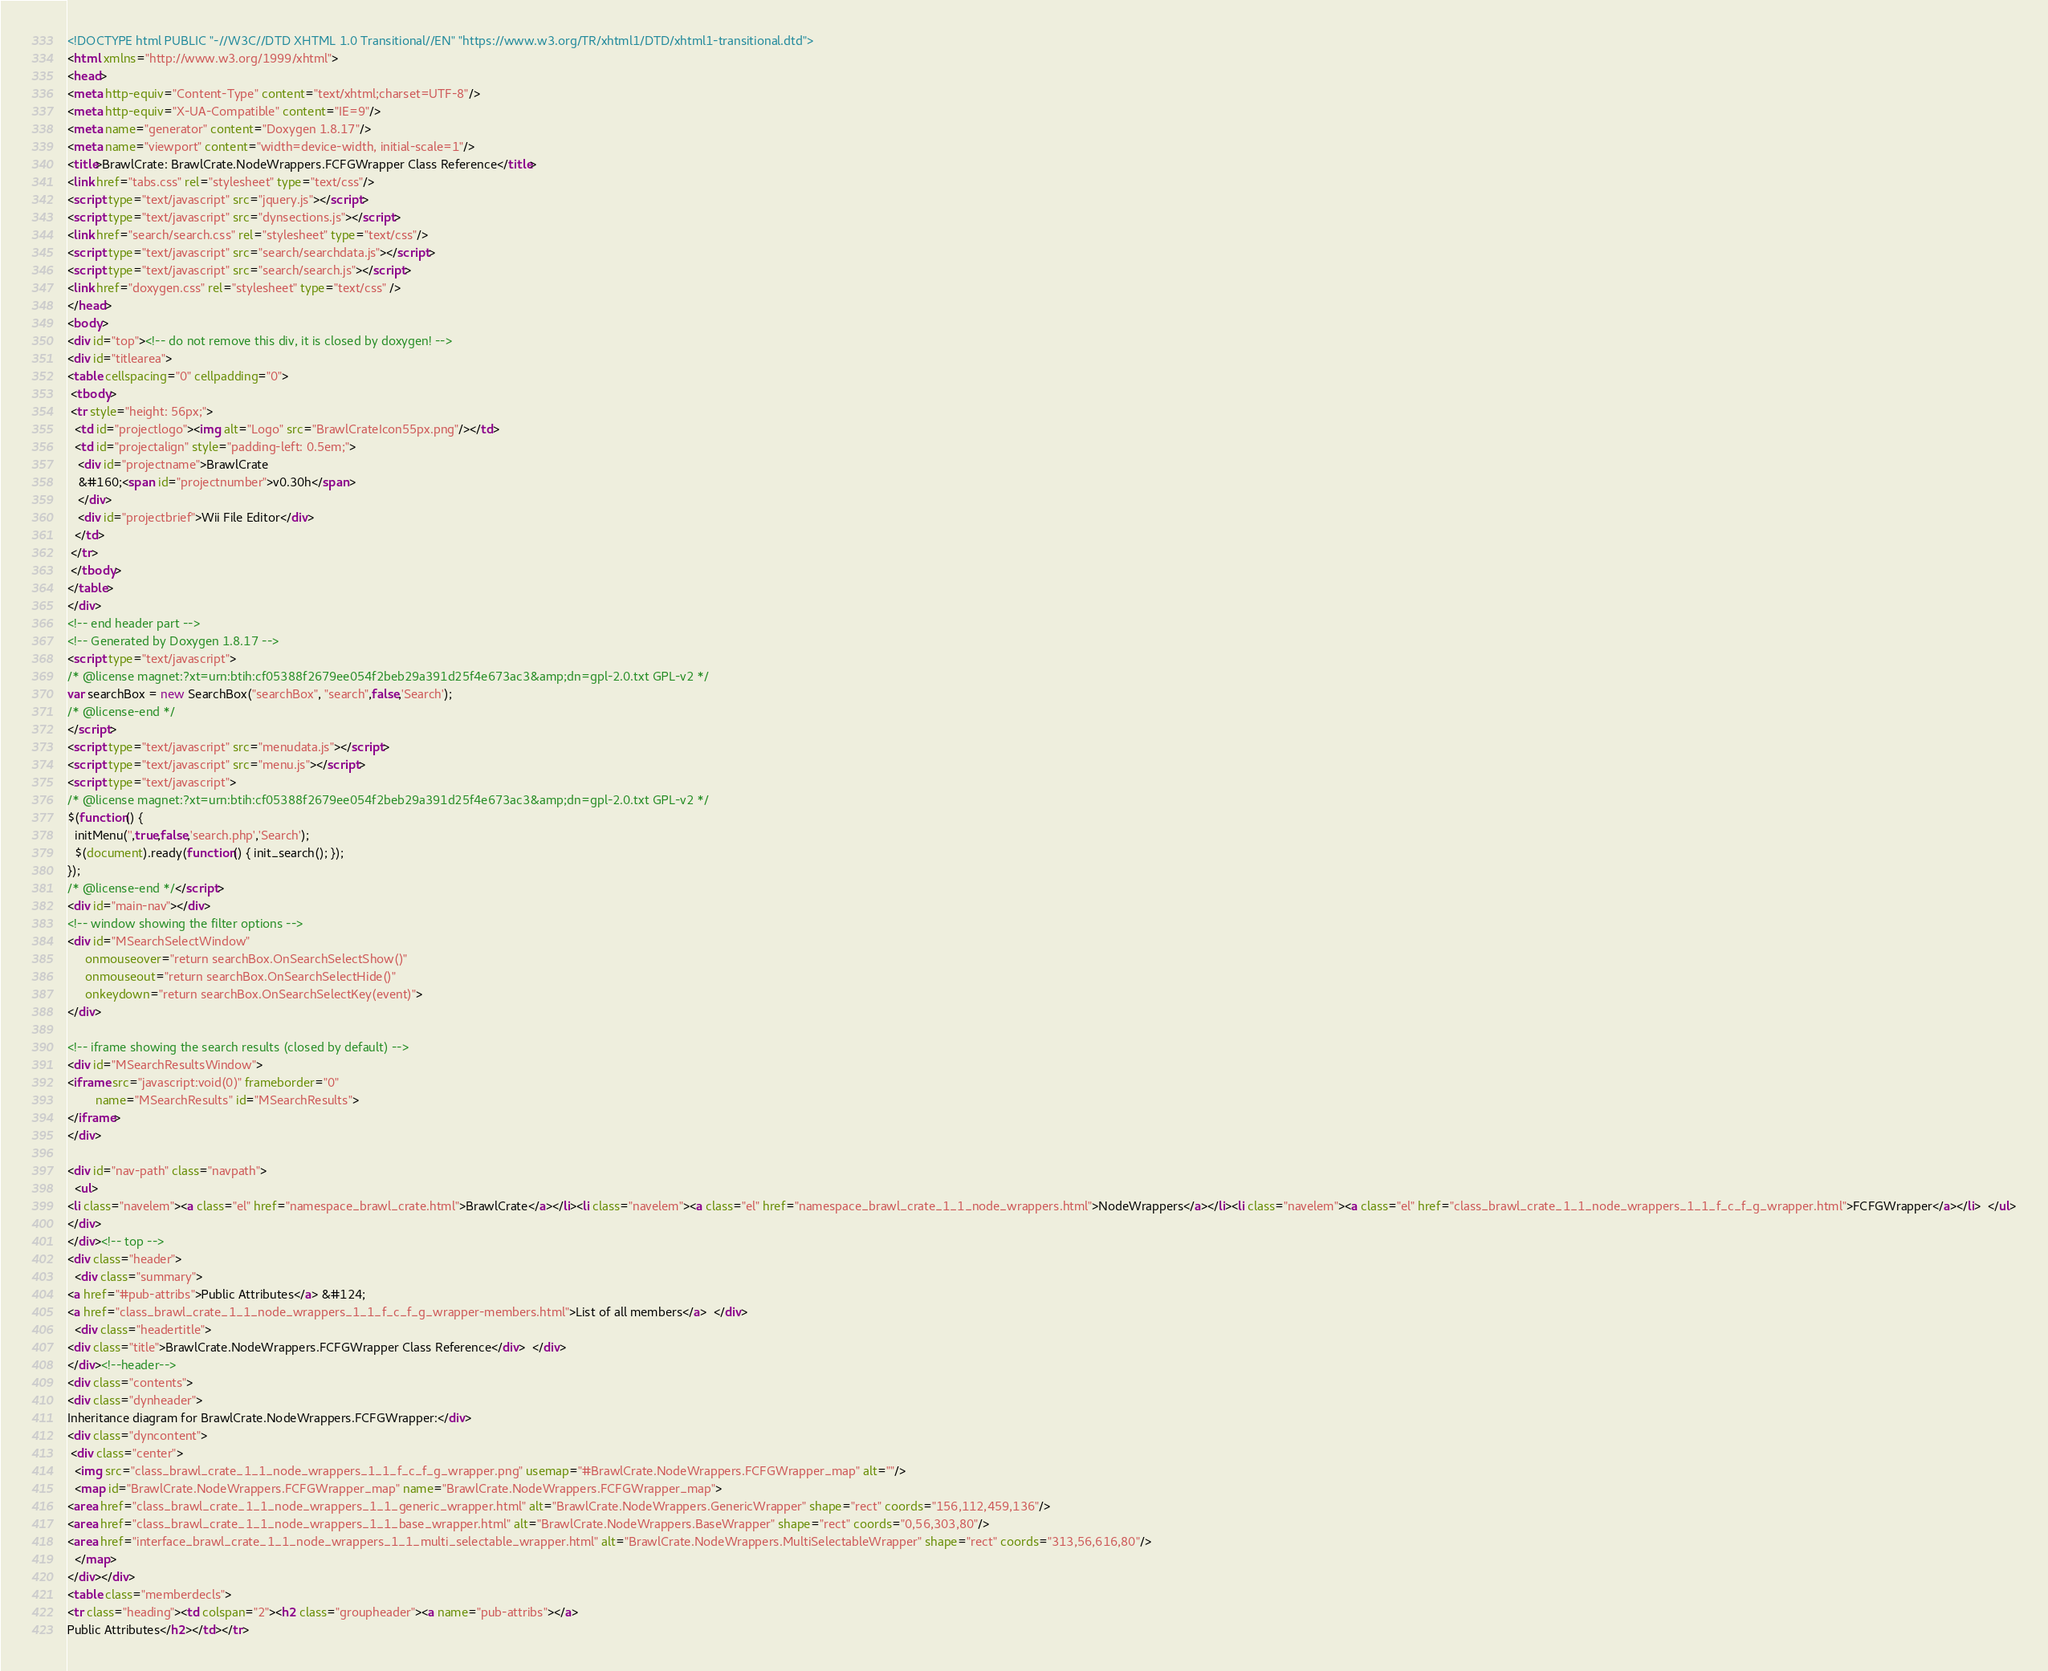<code> <loc_0><loc_0><loc_500><loc_500><_HTML_><!DOCTYPE html PUBLIC "-//W3C//DTD XHTML 1.0 Transitional//EN" "https://www.w3.org/TR/xhtml1/DTD/xhtml1-transitional.dtd">
<html xmlns="http://www.w3.org/1999/xhtml">
<head>
<meta http-equiv="Content-Type" content="text/xhtml;charset=UTF-8"/>
<meta http-equiv="X-UA-Compatible" content="IE=9"/>
<meta name="generator" content="Doxygen 1.8.17"/>
<meta name="viewport" content="width=device-width, initial-scale=1"/>
<title>BrawlCrate: BrawlCrate.NodeWrappers.FCFGWrapper Class Reference</title>
<link href="tabs.css" rel="stylesheet" type="text/css"/>
<script type="text/javascript" src="jquery.js"></script>
<script type="text/javascript" src="dynsections.js"></script>
<link href="search/search.css" rel="stylesheet" type="text/css"/>
<script type="text/javascript" src="search/searchdata.js"></script>
<script type="text/javascript" src="search/search.js"></script>
<link href="doxygen.css" rel="stylesheet" type="text/css" />
</head>
<body>
<div id="top"><!-- do not remove this div, it is closed by doxygen! -->
<div id="titlearea">
<table cellspacing="0" cellpadding="0">
 <tbody>
 <tr style="height: 56px;">
  <td id="projectlogo"><img alt="Logo" src="BrawlCrateIcon55px.png"/></td>
  <td id="projectalign" style="padding-left: 0.5em;">
   <div id="projectname">BrawlCrate
   &#160;<span id="projectnumber">v0.30h</span>
   </div>
   <div id="projectbrief">Wii File Editor</div>
  </td>
 </tr>
 </tbody>
</table>
</div>
<!-- end header part -->
<!-- Generated by Doxygen 1.8.17 -->
<script type="text/javascript">
/* @license magnet:?xt=urn:btih:cf05388f2679ee054f2beb29a391d25f4e673ac3&amp;dn=gpl-2.0.txt GPL-v2 */
var searchBox = new SearchBox("searchBox", "search",false,'Search');
/* @license-end */
</script>
<script type="text/javascript" src="menudata.js"></script>
<script type="text/javascript" src="menu.js"></script>
<script type="text/javascript">
/* @license magnet:?xt=urn:btih:cf05388f2679ee054f2beb29a391d25f4e673ac3&amp;dn=gpl-2.0.txt GPL-v2 */
$(function() {
  initMenu('',true,false,'search.php','Search');
  $(document).ready(function() { init_search(); });
});
/* @license-end */</script>
<div id="main-nav"></div>
<!-- window showing the filter options -->
<div id="MSearchSelectWindow"
     onmouseover="return searchBox.OnSearchSelectShow()"
     onmouseout="return searchBox.OnSearchSelectHide()"
     onkeydown="return searchBox.OnSearchSelectKey(event)">
</div>

<!-- iframe showing the search results (closed by default) -->
<div id="MSearchResultsWindow">
<iframe src="javascript:void(0)" frameborder="0" 
        name="MSearchResults" id="MSearchResults">
</iframe>
</div>

<div id="nav-path" class="navpath">
  <ul>
<li class="navelem"><a class="el" href="namespace_brawl_crate.html">BrawlCrate</a></li><li class="navelem"><a class="el" href="namespace_brawl_crate_1_1_node_wrappers.html">NodeWrappers</a></li><li class="navelem"><a class="el" href="class_brawl_crate_1_1_node_wrappers_1_1_f_c_f_g_wrapper.html">FCFGWrapper</a></li>  </ul>
</div>
</div><!-- top -->
<div class="header">
  <div class="summary">
<a href="#pub-attribs">Public Attributes</a> &#124;
<a href="class_brawl_crate_1_1_node_wrappers_1_1_f_c_f_g_wrapper-members.html">List of all members</a>  </div>
  <div class="headertitle">
<div class="title">BrawlCrate.NodeWrappers.FCFGWrapper Class Reference</div>  </div>
</div><!--header-->
<div class="contents">
<div class="dynheader">
Inheritance diagram for BrawlCrate.NodeWrappers.FCFGWrapper:</div>
<div class="dyncontent">
 <div class="center">
  <img src="class_brawl_crate_1_1_node_wrappers_1_1_f_c_f_g_wrapper.png" usemap="#BrawlCrate.NodeWrappers.FCFGWrapper_map" alt=""/>
  <map id="BrawlCrate.NodeWrappers.FCFGWrapper_map" name="BrawlCrate.NodeWrappers.FCFGWrapper_map">
<area href="class_brawl_crate_1_1_node_wrappers_1_1_generic_wrapper.html" alt="BrawlCrate.NodeWrappers.GenericWrapper" shape="rect" coords="156,112,459,136"/>
<area href="class_brawl_crate_1_1_node_wrappers_1_1_base_wrapper.html" alt="BrawlCrate.NodeWrappers.BaseWrapper" shape="rect" coords="0,56,303,80"/>
<area href="interface_brawl_crate_1_1_node_wrappers_1_1_multi_selectable_wrapper.html" alt="BrawlCrate.NodeWrappers.MultiSelectableWrapper" shape="rect" coords="313,56,616,80"/>
  </map>
</div></div>
<table class="memberdecls">
<tr class="heading"><td colspan="2"><h2 class="groupheader"><a name="pub-attribs"></a>
Public Attributes</h2></td></tr></code> 